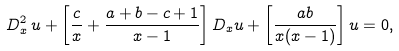<formula> <loc_0><loc_0><loc_500><loc_500>D _ { x } ^ { 2 } \, u + \left [ \frac { c } { x } + \frac { a + b - c + 1 } { x - 1 } \right ] D _ { x } u + \left [ \frac { a b } { x ( x - 1 ) } \right ] u = 0 ,</formula> 